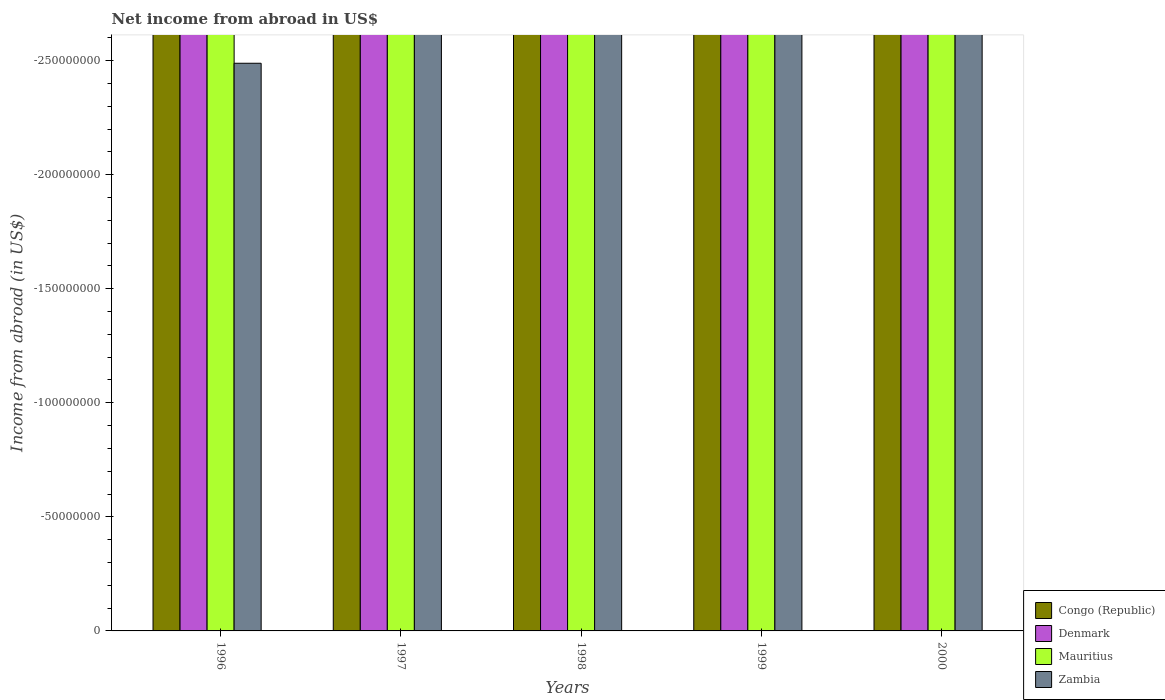How many different coloured bars are there?
Keep it short and to the point. 0. Are the number of bars per tick equal to the number of legend labels?
Keep it short and to the point. No. How many bars are there on the 3rd tick from the right?
Your answer should be very brief. 0. What is the label of the 5th group of bars from the left?
Ensure brevity in your answer.  2000. In how many cases, is the number of bars for a given year not equal to the number of legend labels?
Provide a short and direct response. 5. Across all years, what is the minimum net income from abroad in Zambia?
Provide a succinct answer. 0. What is the total net income from abroad in Denmark in the graph?
Offer a terse response. 0. What is the average net income from abroad in Congo (Republic) per year?
Give a very brief answer. 0. In how many years, is the net income from abroad in Congo (Republic) greater than -100000000 US$?
Offer a terse response. 0. Is it the case that in every year, the sum of the net income from abroad in Denmark and net income from abroad in Congo (Republic) is greater than the net income from abroad in Zambia?
Provide a succinct answer. No. How many bars are there?
Provide a succinct answer. 0. How many years are there in the graph?
Ensure brevity in your answer.  5. Are the values on the major ticks of Y-axis written in scientific E-notation?
Make the answer very short. No. Does the graph contain any zero values?
Give a very brief answer. Yes. Does the graph contain grids?
Your answer should be very brief. No. How many legend labels are there?
Give a very brief answer. 4. What is the title of the graph?
Provide a succinct answer. Net income from abroad in US$. Does "New Zealand" appear as one of the legend labels in the graph?
Offer a terse response. No. What is the label or title of the X-axis?
Provide a short and direct response. Years. What is the label or title of the Y-axis?
Provide a short and direct response. Income from abroad (in US$). What is the Income from abroad (in US$) of Congo (Republic) in 1996?
Give a very brief answer. 0. What is the Income from abroad (in US$) of Denmark in 1996?
Offer a terse response. 0. What is the Income from abroad (in US$) of Zambia in 1996?
Make the answer very short. 0. What is the Income from abroad (in US$) in Congo (Republic) in 1998?
Offer a very short reply. 0. What is the Income from abroad (in US$) in Mauritius in 1998?
Your answer should be very brief. 0. What is the Income from abroad (in US$) of Zambia in 1998?
Your answer should be compact. 0. What is the Income from abroad (in US$) in Denmark in 1999?
Your answer should be compact. 0. What is the Income from abroad (in US$) in Zambia in 1999?
Offer a very short reply. 0. What is the Income from abroad (in US$) in Denmark in 2000?
Keep it short and to the point. 0. What is the Income from abroad (in US$) in Zambia in 2000?
Make the answer very short. 0. What is the total Income from abroad (in US$) in Denmark in the graph?
Offer a very short reply. 0. What is the total Income from abroad (in US$) of Mauritius in the graph?
Your answer should be compact. 0. What is the average Income from abroad (in US$) of Denmark per year?
Give a very brief answer. 0. 